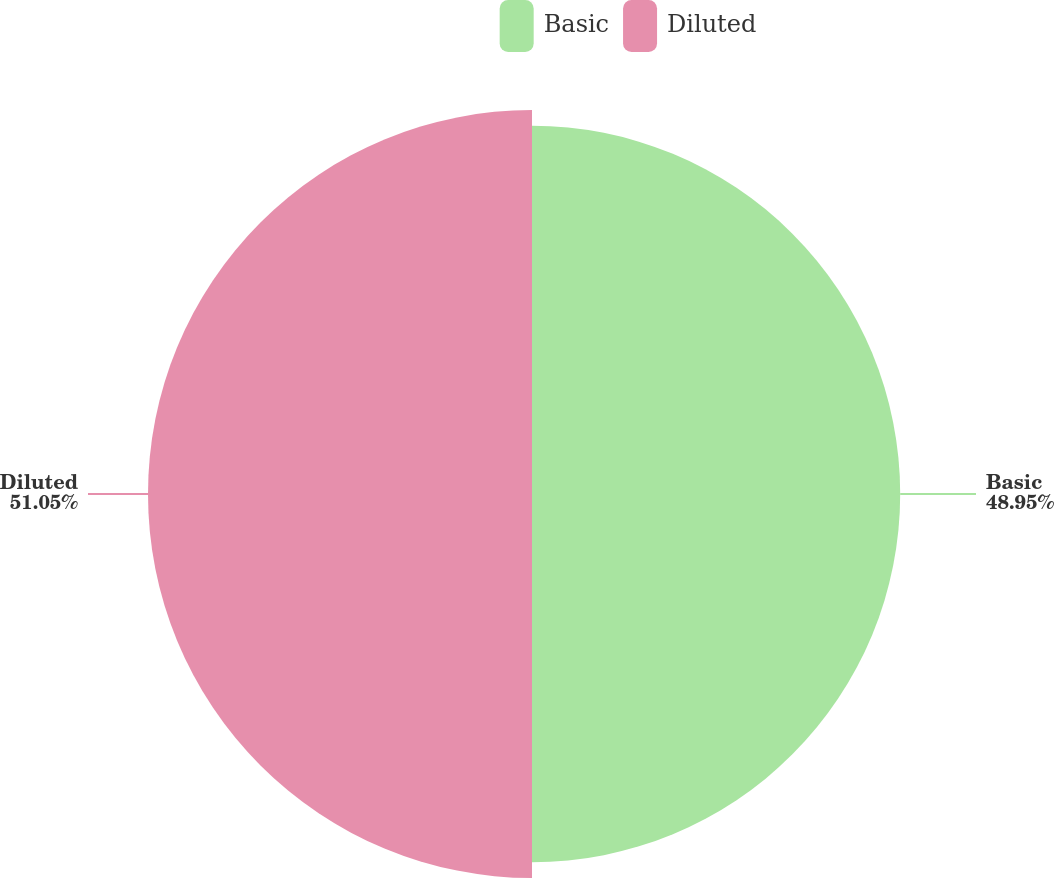Convert chart. <chart><loc_0><loc_0><loc_500><loc_500><pie_chart><fcel>Basic<fcel>Diluted<nl><fcel>48.95%<fcel>51.05%<nl></chart> 